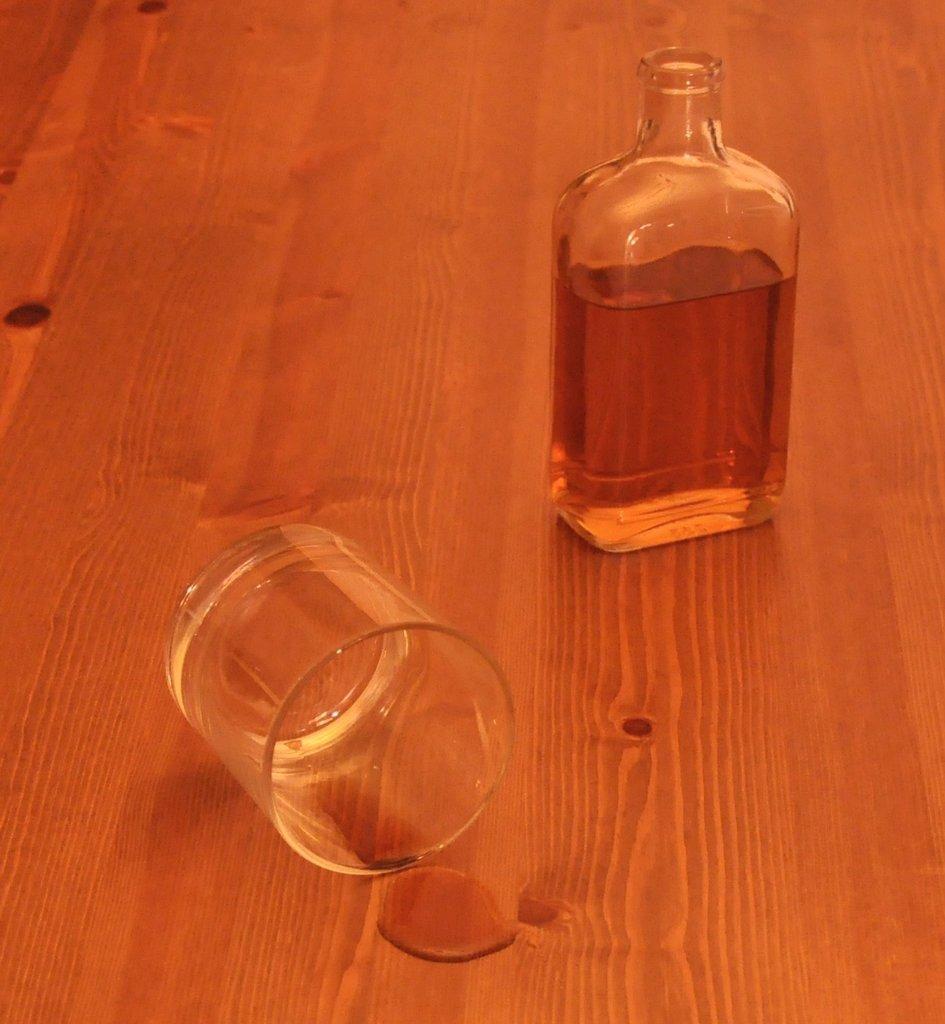Please provide a concise description of this image. In a picture there is one glass and one bottle with some drink in it. 